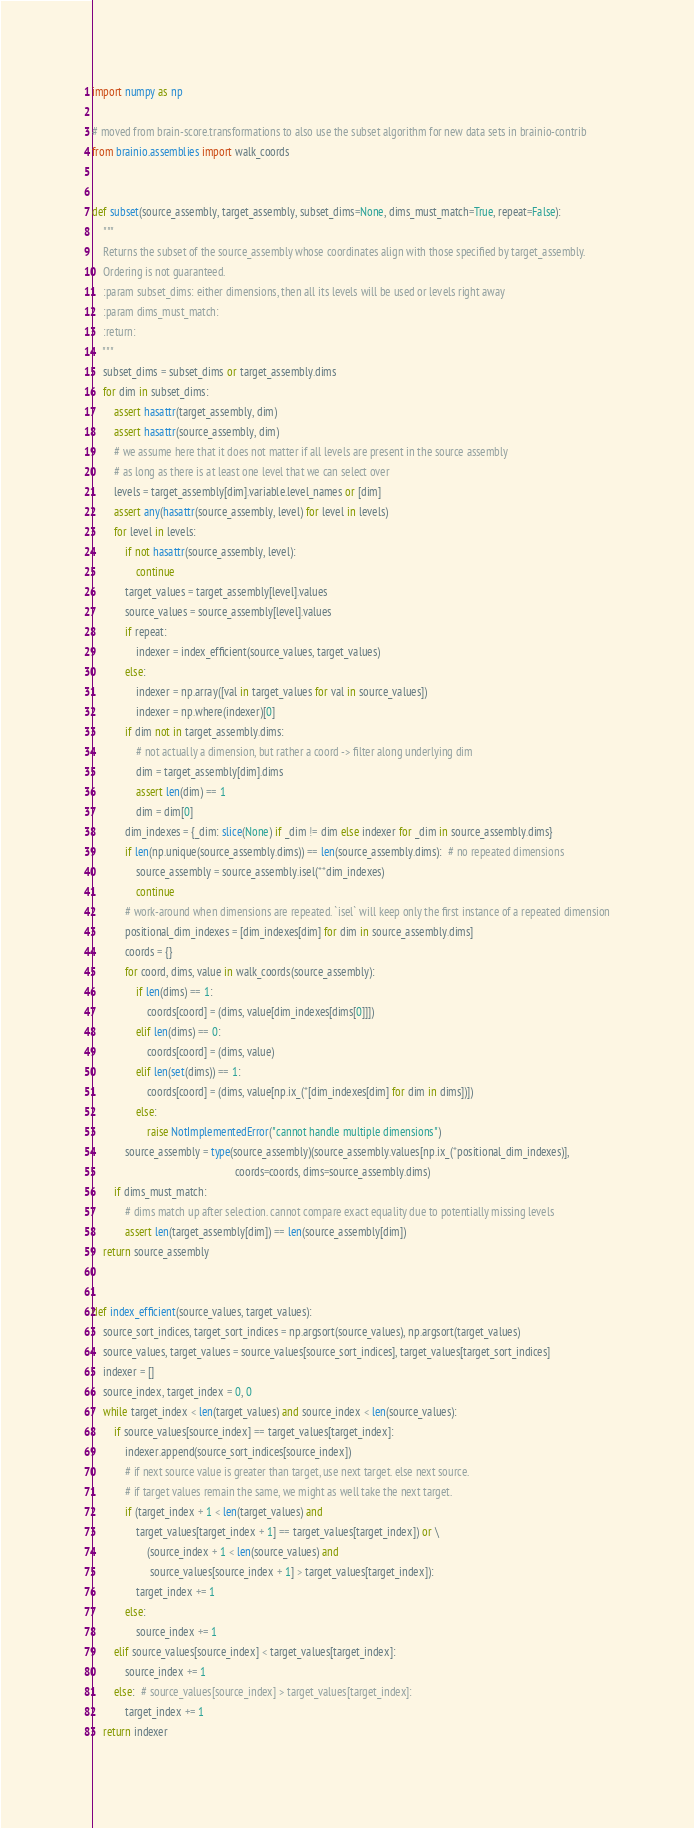Convert code to text. <code><loc_0><loc_0><loc_500><loc_500><_Python_>import numpy as np

# moved from brain-score.transformations to also use the subset algorithm for new data sets in brainio-contrib
from brainio.assemblies import walk_coords


def subset(source_assembly, target_assembly, subset_dims=None, dims_must_match=True, repeat=False):
    """
    Returns the subset of the source_assembly whose coordinates align with those specified by target_assembly.
    Ordering is not guaranteed.
    :param subset_dims: either dimensions, then all its levels will be used or levels right away
    :param dims_must_match:
    :return:
    """
    subset_dims = subset_dims or target_assembly.dims
    for dim in subset_dims:
        assert hasattr(target_assembly, dim)
        assert hasattr(source_assembly, dim)
        # we assume here that it does not matter if all levels are present in the source assembly
        # as long as there is at least one level that we can select over
        levels = target_assembly[dim].variable.level_names or [dim]
        assert any(hasattr(source_assembly, level) for level in levels)
        for level in levels:
            if not hasattr(source_assembly, level):
                continue
            target_values = target_assembly[level].values
            source_values = source_assembly[level].values
            if repeat:
                indexer = index_efficient(source_values, target_values)
            else:
                indexer = np.array([val in target_values for val in source_values])
                indexer = np.where(indexer)[0]
            if dim not in target_assembly.dims:
                # not actually a dimension, but rather a coord -> filter along underlying dim
                dim = target_assembly[dim].dims
                assert len(dim) == 1
                dim = dim[0]
            dim_indexes = {_dim: slice(None) if _dim != dim else indexer for _dim in source_assembly.dims}
            if len(np.unique(source_assembly.dims)) == len(source_assembly.dims):  # no repeated dimensions
                source_assembly = source_assembly.isel(**dim_indexes)
                continue
            # work-around when dimensions are repeated. `isel` will keep only the first instance of a repeated dimension
            positional_dim_indexes = [dim_indexes[dim] for dim in source_assembly.dims]
            coords = {}
            for coord, dims, value in walk_coords(source_assembly):
                if len(dims) == 1:
                    coords[coord] = (dims, value[dim_indexes[dims[0]]])
                elif len(dims) == 0:
                    coords[coord] = (dims, value)
                elif len(set(dims)) == 1:
                    coords[coord] = (dims, value[np.ix_(*[dim_indexes[dim] for dim in dims])])
                else:
                    raise NotImplementedError("cannot handle multiple dimensions")
            source_assembly = type(source_assembly)(source_assembly.values[np.ix_(*positional_dim_indexes)],
                                                    coords=coords, dims=source_assembly.dims)
        if dims_must_match:
            # dims match up after selection. cannot compare exact equality due to potentially missing levels
            assert len(target_assembly[dim]) == len(source_assembly[dim])
    return source_assembly


def index_efficient(source_values, target_values):
    source_sort_indices, target_sort_indices = np.argsort(source_values), np.argsort(target_values)
    source_values, target_values = source_values[source_sort_indices], target_values[target_sort_indices]
    indexer = []
    source_index, target_index = 0, 0
    while target_index < len(target_values) and source_index < len(source_values):
        if source_values[source_index] == target_values[target_index]:
            indexer.append(source_sort_indices[source_index])
            # if next source value is greater than target, use next target. else next source.
            # if target values remain the same, we might as well take the next target.
            if (target_index + 1 < len(target_values) and
                target_values[target_index + 1] == target_values[target_index]) or \
                    (source_index + 1 < len(source_values) and
                     source_values[source_index + 1] > target_values[target_index]):
                target_index += 1
            else:
                source_index += 1
        elif source_values[source_index] < target_values[target_index]:
            source_index += 1
        else:  # source_values[source_index] > target_values[target_index]:
            target_index += 1
    return indexer
</code> 